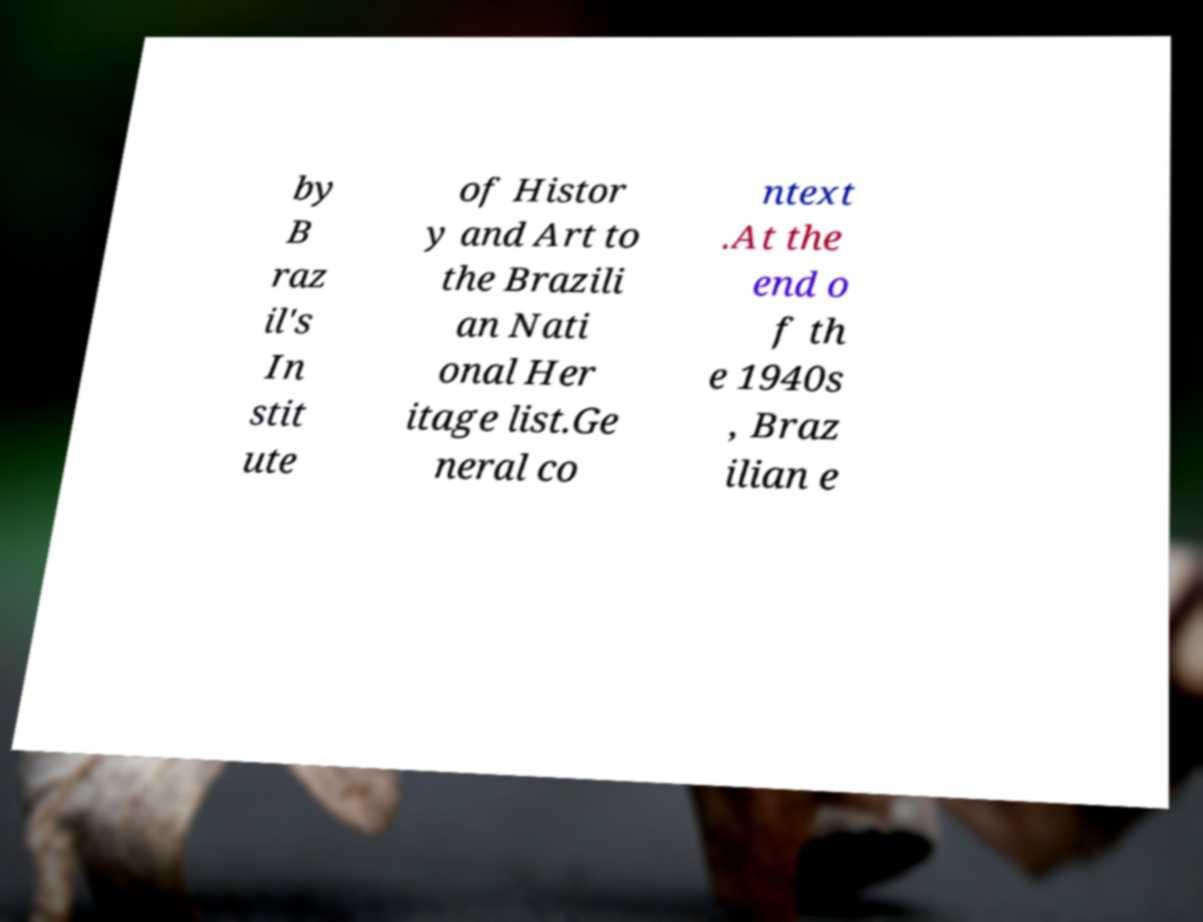Can you accurately transcribe the text from the provided image for me? by B raz il's In stit ute of Histor y and Art to the Brazili an Nati onal Her itage list.Ge neral co ntext .At the end o f th e 1940s , Braz ilian e 